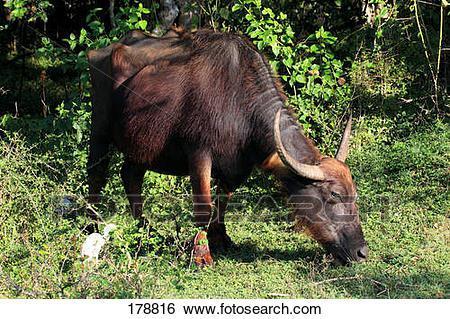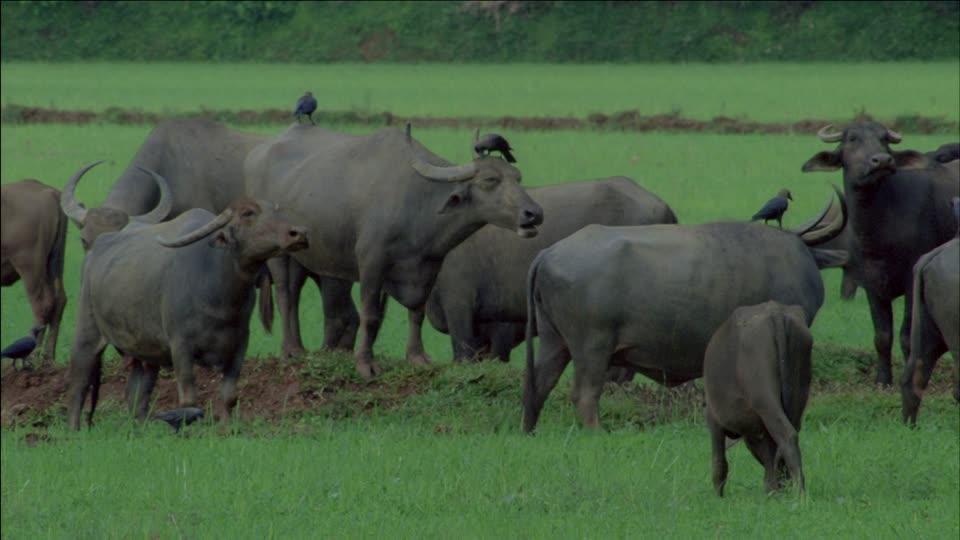The first image is the image on the left, the second image is the image on the right. Evaluate the accuracy of this statement regarding the images: "There are exactly three animals with horns that are visible.". Is it true? Answer yes or no. No. The first image is the image on the left, the second image is the image on the right. For the images displayed, is the sentence "There are exactly three animals in total." factually correct? Answer yes or no. No. 